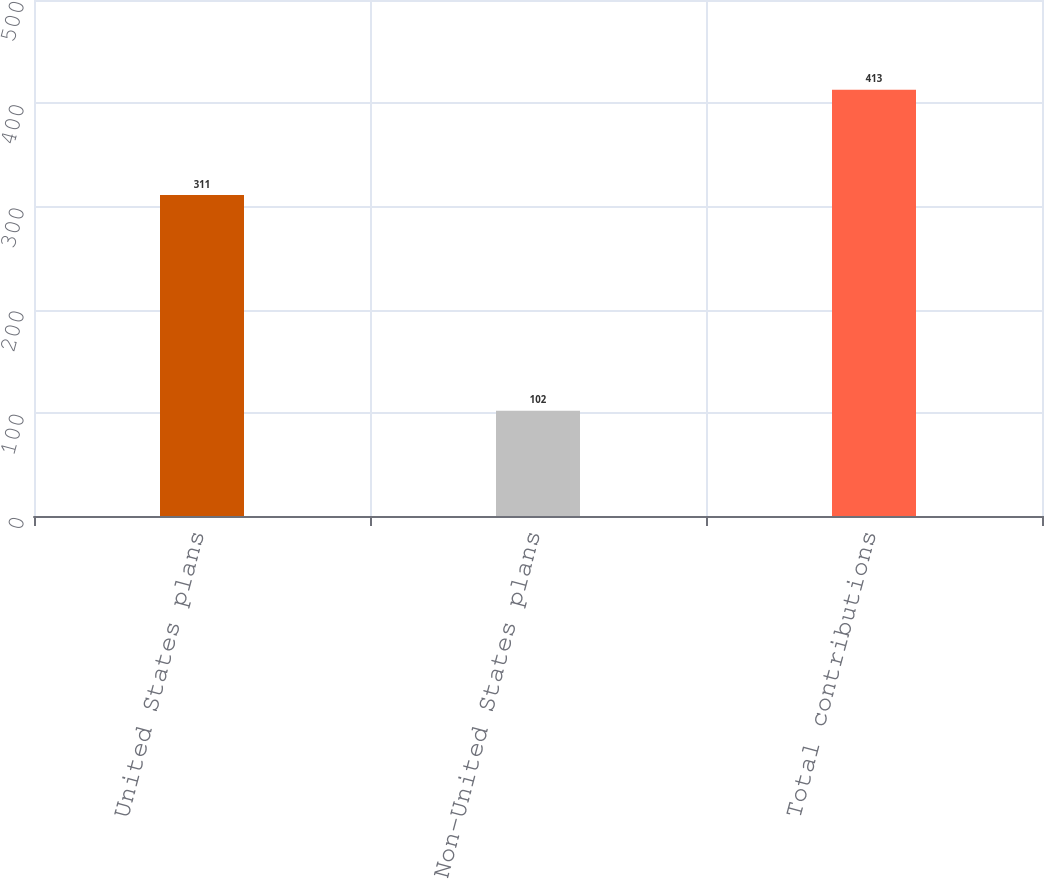Convert chart. <chart><loc_0><loc_0><loc_500><loc_500><bar_chart><fcel>United States plans<fcel>Non-United States plans<fcel>Total contributions<nl><fcel>311<fcel>102<fcel>413<nl></chart> 